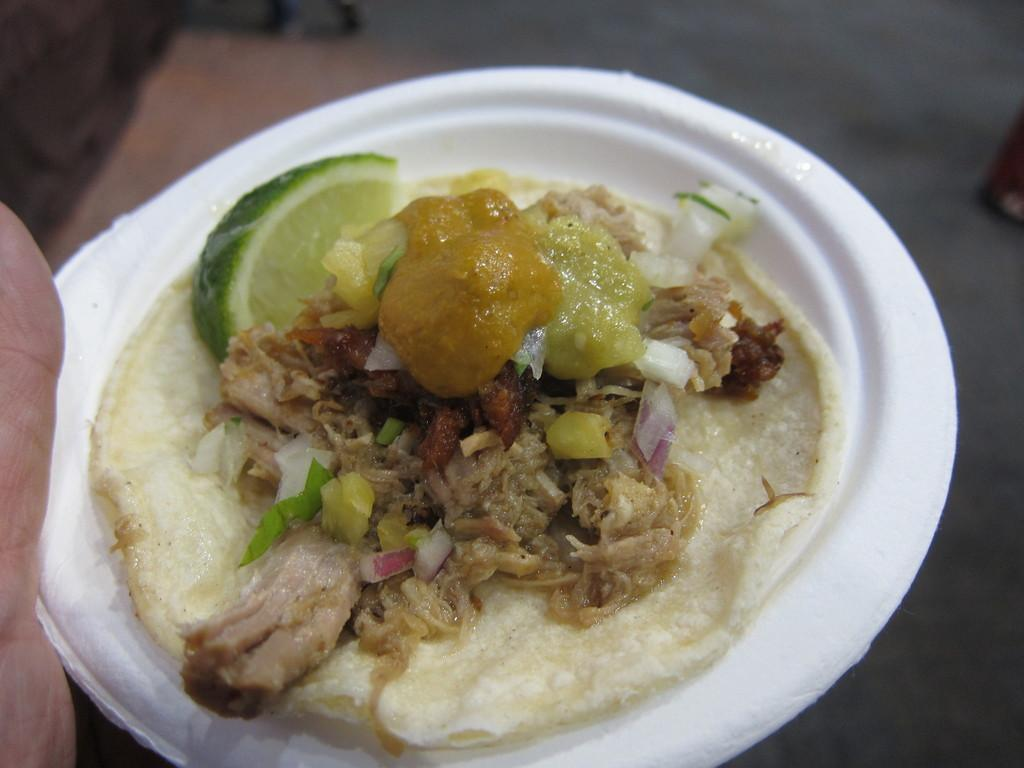What is the main subject of the image? There is a person in the image. What is the person holding in the image? The person is holding a bowl. What is inside the bowl that the person is holding? There is food in the bowl. What hobbies does the person have, as seen in the image? The image does not provide information about the person's hobbies. Can you tell me how many spots are visible on the person in the image? There are no spots visible on the person in the image. 